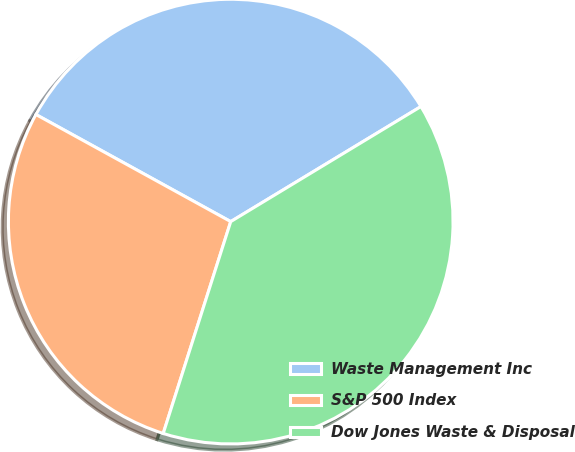<chart> <loc_0><loc_0><loc_500><loc_500><pie_chart><fcel>Waste Management Inc<fcel>S&P 500 Index<fcel>Dow Jones Waste & Disposal<nl><fcel>33.34%<fcel>28.09%<fcel>38.57%<nl></chart> 